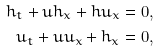Convert formula to latex. <formula><loc_0><loc_0><loc_500><loc_500>h _ { t } + u h _ { x } + h u _ { x } = 0 , \\ u _ { t } + u u _ { x } + h _ { x } = 0 ,</formula> 